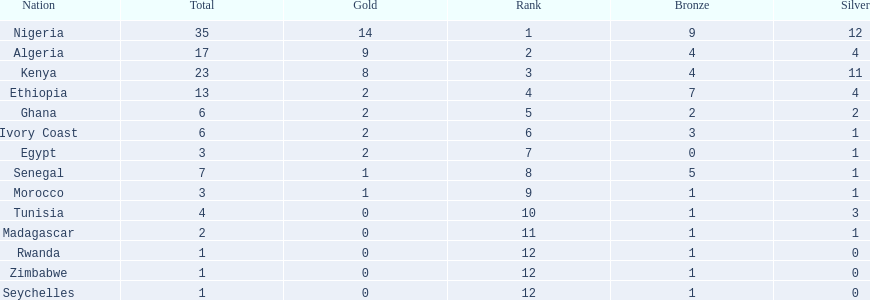What was the total number of medals the ivory coast won? 6. 